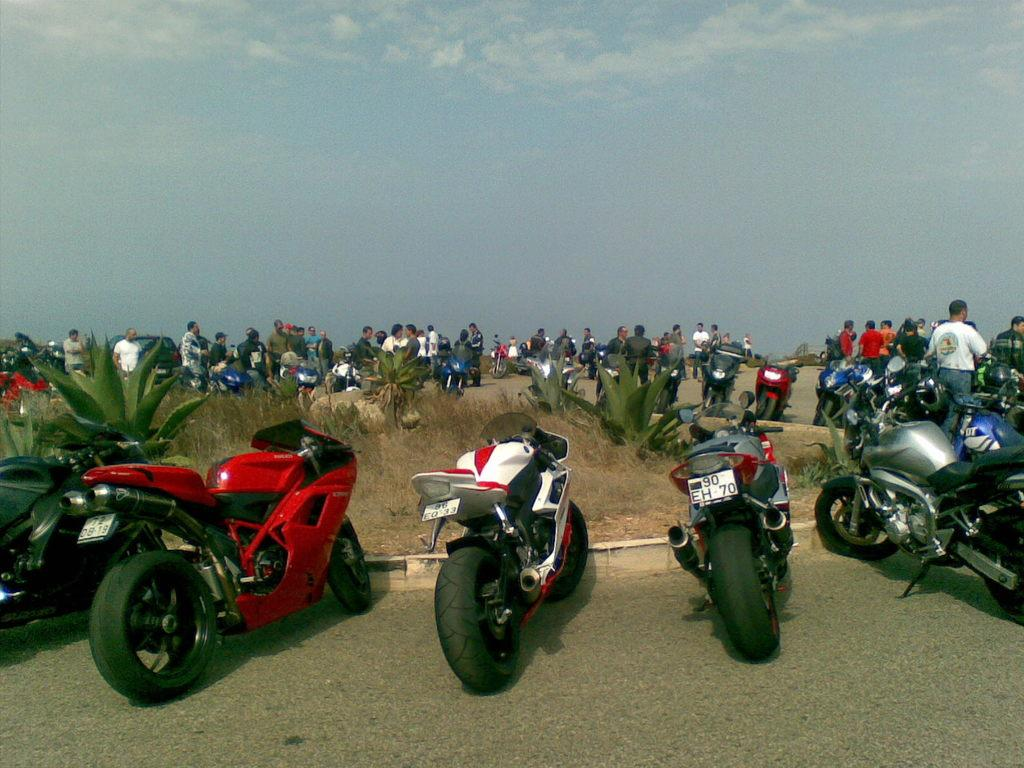What is parked on the road in the image? There is a bike parked on the road in the image. What else can be seen in the image besides the bike? Plants are visible in the image, and people are walking on the road in the background. What is visible in the background of the image? The sky is visible in the background, and clouds are present in the sky. What type of plate is being used to compare the size of the clouds in the image? There is no plate present in the image, and the clouds are not being compared in size. 